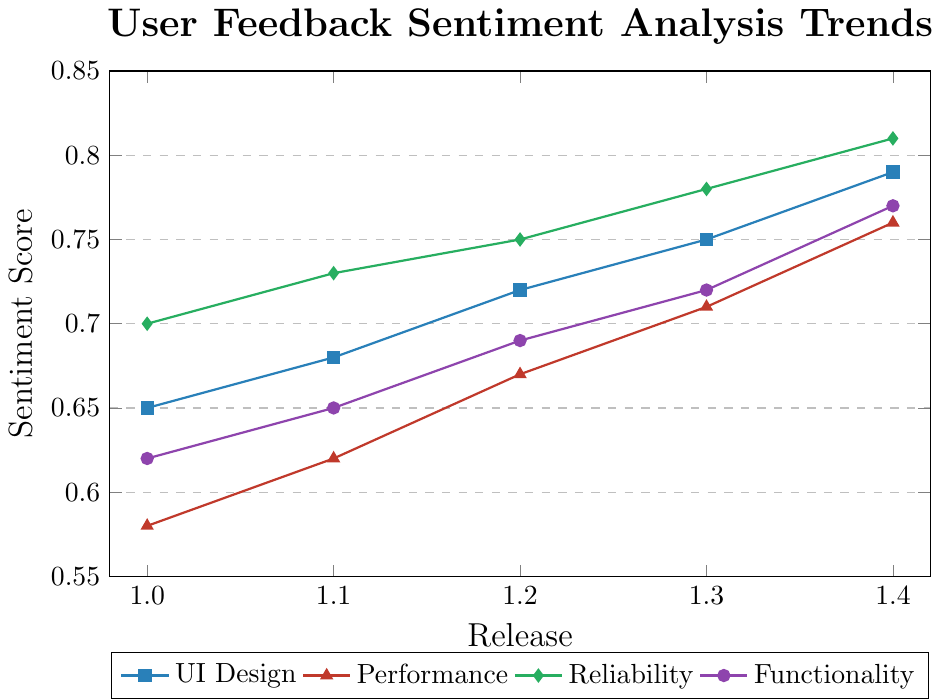What is the sentiment score for UI Design at Release 1.2? Locate the UI Design line and find the point for Release 1.2. The sentiment score at this point is 0.72
Answer: 0.72 Which feature experienced the highest sentiment score improvement from Release 1.0 to Release 1.4? Calculate the difference in sentiment scores from Release 1.0 to 1.4 for each feature. UI Design: 0.79 - 0.65 = 0.14, Performance: 0.76 - 0.58 = 0.18, Reliability: 0.81 - 0.70 = 0.11, Functionality: 0.77 - 0.62 = 0.15. Performance has the highest improvement (0.18)
Answer: Performance Compare the sentiment scores for Performance and Reliability at Release 1.3. Which one is higher? Find the sentiment scores for Performance (0.71) and Reliability (0.78) at Release 1.3 and compare them. 0.78 (Reliability) > 0.71 (Performance)
Answer: Reliability How much did the sentiment score for Functionality increase between Release 1.1 and Release 1.3? Subtract the sentiment score for Release 1.1 from the sentiment score for Release 1.3 for Functionality. 0.72 - 0.65 = 0.07
Answer: 0.07 At Release 1.1, which feature had the lowest sentiment score? Find the sentiment scores for all features at Release 1.1. UI Design: 0.68, Performance: 0.62, Reliability: 0.73, Functionality: 0.65. Performance has the lowest score (0.62)
Answer: Performance What is the average sentiment score of all features at Release 1.4? Calculate the average sentiment score for all features at Release 1.4. (0.79 (UI Design) + 0.76 (Performance) + 0.81 (Reliability) + 0.77 (Functionality)) / 4 = 0.7825
Answer: 0.7825 Does Performance ever surpass Functionality in sentiment score within the releases shown? Compare the sentiment scores of Performance and Functionality across all releases. At each release (1.0, 1.1, 1.2, 1.3, 1.4), the sentiment score for Performance is never greater than Functionality's score.
Answer: No Which feature had the most consistent increase in sentiment score across all releases? Analyze the sentiment score increments for each release of all features. All features show consistent increases, but comparing the increments shows UI Design and Reliability as slightly smoother than others. Both have consistent increases without any drops or irregular jumps.
Answer: UI Design, Reliability What was the difference in sentiment score between UI Design and Performance at Release 1.4? Subtract the sentiment score for Performance from the sentiment score for UI Design at Release 1.4. 0.79 - 0.76 = 0.03
Answer: 0.03 Which feature's sentiment score surpasses 0.80 first among all the releases? Look at the sentiment scores across releases and identify the first instance where a score exceeds 0.80. Reliability first reaches a score of 0.81 at Release 1.4.
Answer: Reliability 